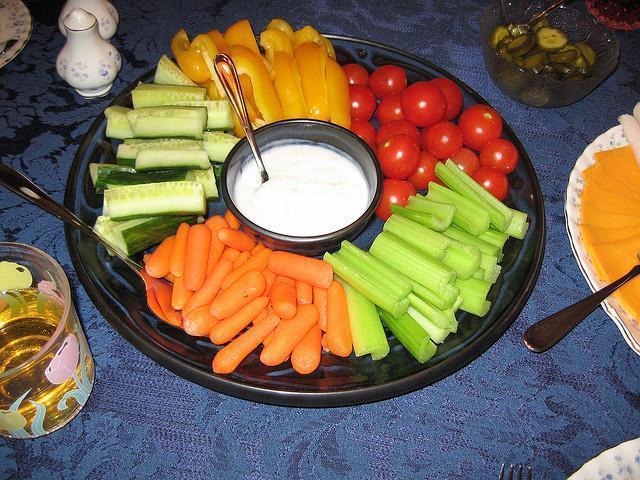What type of utensil is resting in the middle of the bowl in the cup?
Pick the correct solution from the four options below to address the question.
Options: Fork, knife, spoon, chopsticks. Spoon. 